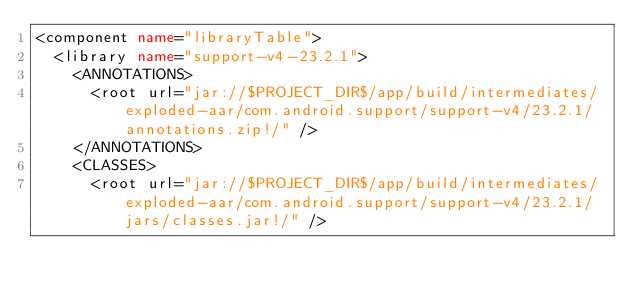<code> <loc_0><loc_0><loc_500><loc_500><_XML_><component name="libraryTable">
  <library name="support-v4-23.2.1">
    <ANNOTATIONS>
      <root url="jar://$PROJECT_DIR$/app/build/intermediates/exploded-aar/com.android.support/support-v4/23.2.1/annotations.zip!/" />
    </ANNOTATIONS>
    <CLASSES>
      <root url="jar://$PROJECT_DIR$/app/build/intermediates/exploded-aar/com.android.support/support-v4/23.2.1/jars/classes.jar!/" /></code> 